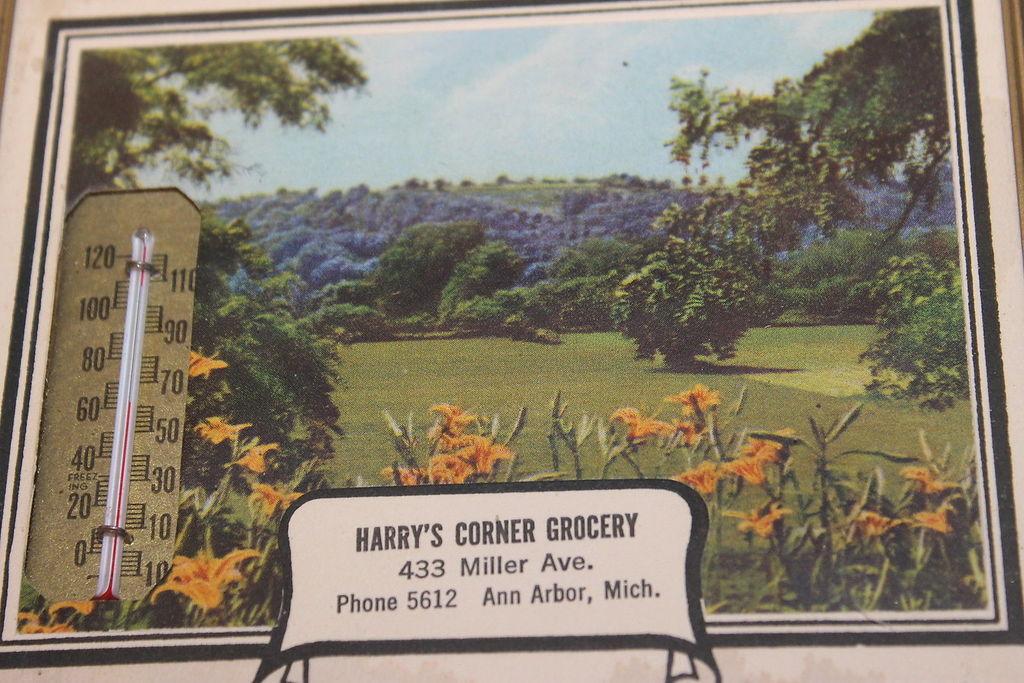What is the address?
Your response must be concise. 433 miller ave. What city is this in?
Your answer should be very brief. Ann arbor. 